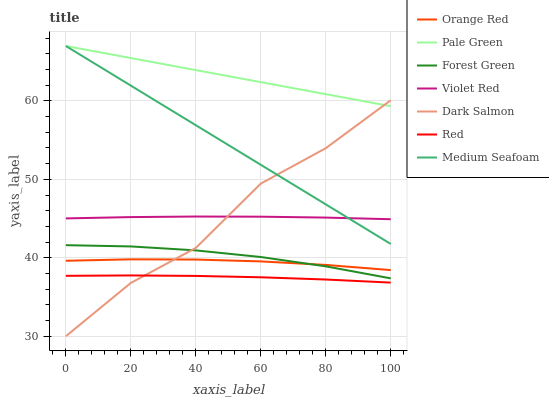Does Red have the minimum area under the curve?
Answer yes or no. Yes. Does Pale Green have the maximum area under the curve?
Answer yes or no. Yes. Does Dark Salmon have the minimum area under the curve?
Answer yes or no. No. Does Dark Salmon have the maximum area under the curve?
Answer yes or no. No. Is Medium Seafoam the smoothest?
Answer yes or no. Yes. Is Dark Salmon the roughest?
Answer yes or no. Yes. Is Dark Salmon the smoothest?
Answer yes or no. No. Is Medium Seafoam the roughest?
Answer yes or no. No. Does Medium Seafoam have the lowest value?
Answer yes or no. No. Does Pale Green have the highest value?
Answer yes or no. Yes. Does Dark Salmon have the highest value?
Answer yes or no. No. Is Forest Green less than Pale Green?
Answer yes or no. Yes. Is Violet Red greater than Orange Red?
Answer yes or no. Yes. Does Forest Green intersect Pale Green?
Answer yes or no. No. 